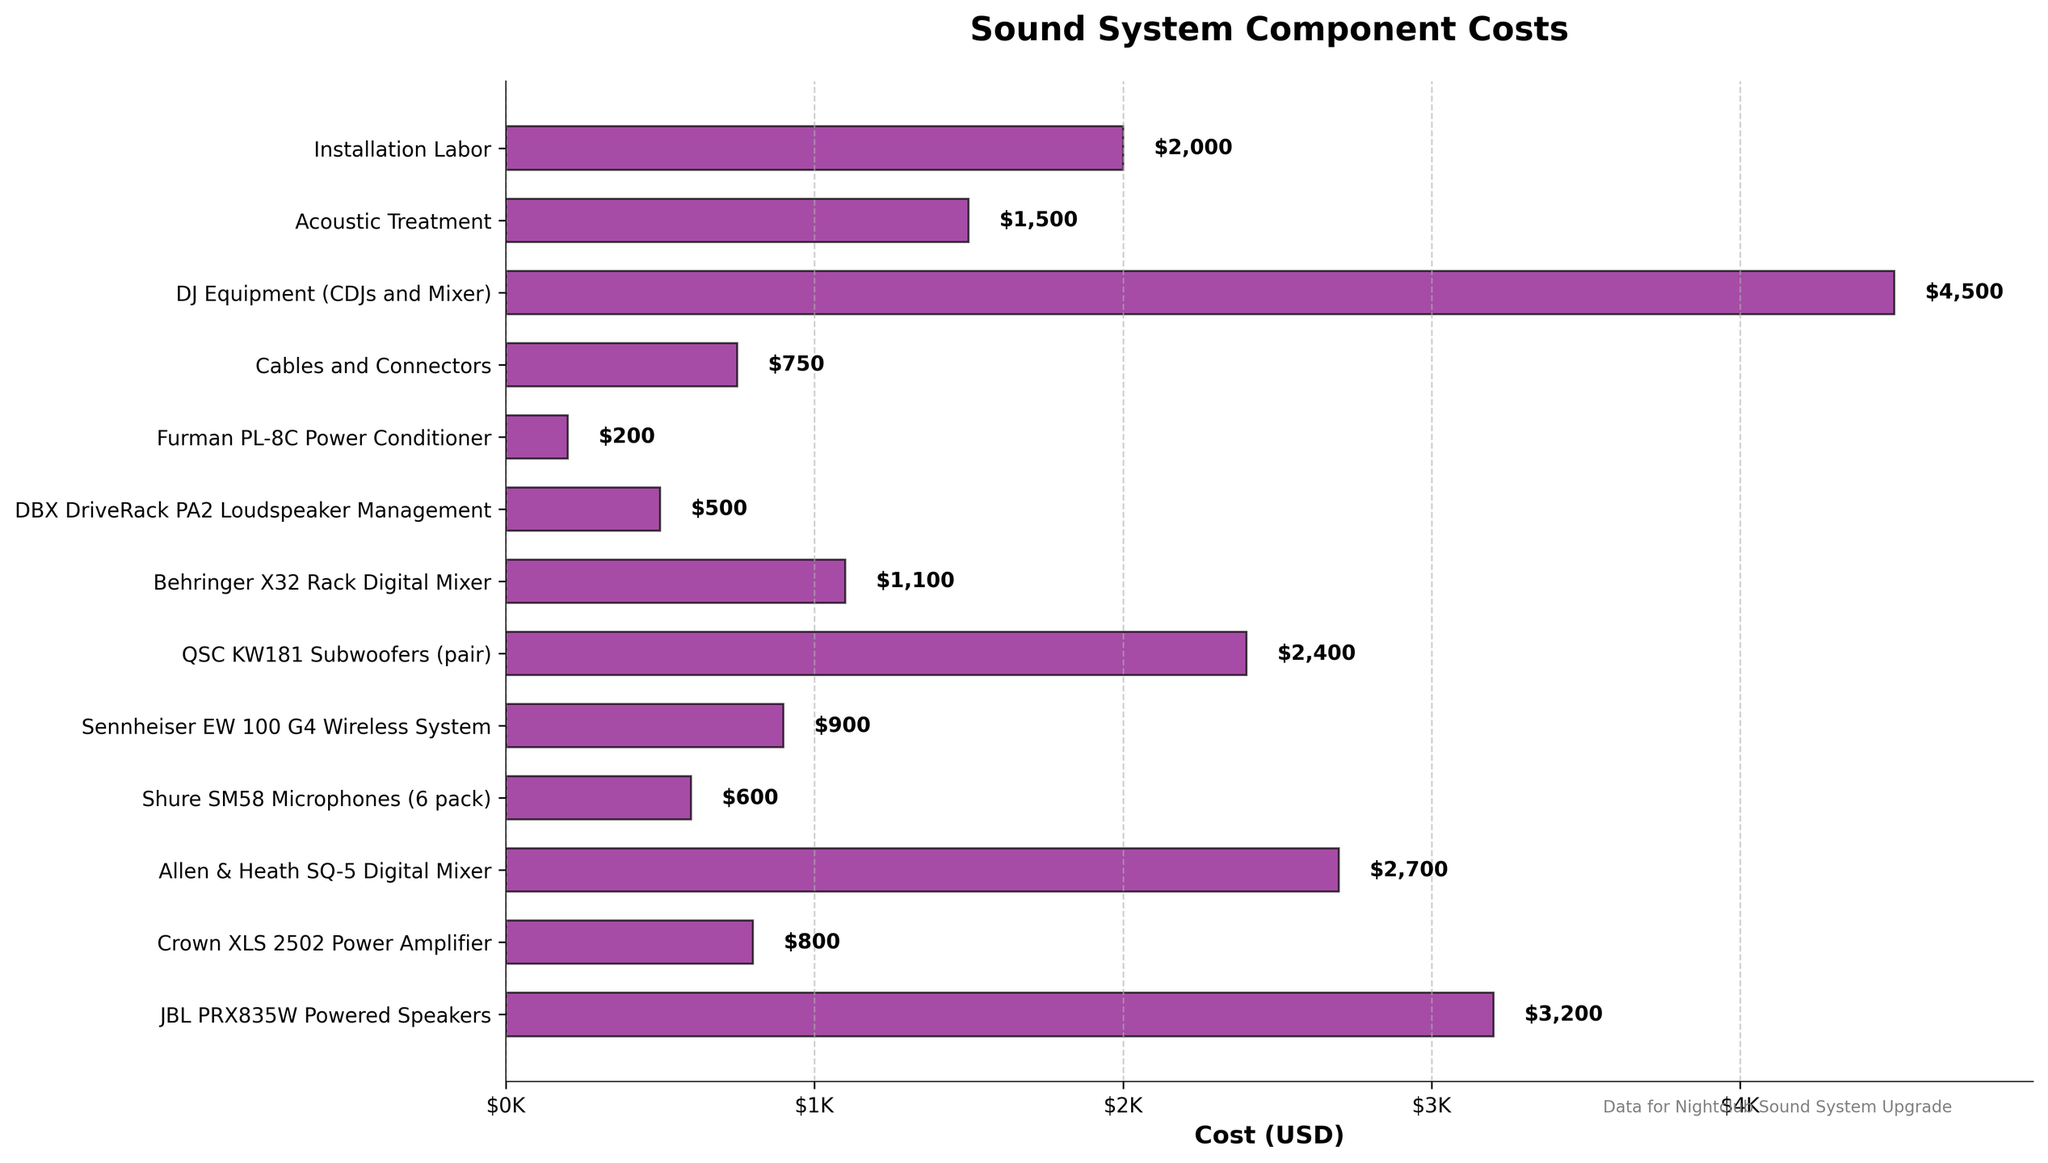What is the most expensive component in the sound system? The horizontal bar chart shows different components with their corresponding costs in USD. The longest bar corresponds to the DJ Equipment (CDJs and Mixer) with a cost of $4,500, which is the highest cost among all components.
Answer: DJ Equipment (CDJs and Mixer) What is the total cost of the digital mixers? The Allen & Heath SQ-5 Digital Mixer costs $2,700 and the Behringer X32 Rack Digital Mixer costs $1,100. Adding these two costs together gives $2,700 + $1,100 = $3,800.
Answer: $3,800 Which component is more expensive, the JBL PRX835W Powered Speakers or the QSC KW181 Subwoofers (pair)? Comparing the horizontal bar lengths, the JBL PRX835W Powered Speakers cost $3,200, while the QSC KW181 Subwoofers (pair) cost $2,400. Since $3,200 is greater than $2,400, the JBL PRX835W Powered Speakers are more expensive.
Answer: JBL PRX835W Powered Speakers What is the cost difference between the Installation Labor and the Acoustic Treatment? The Installation Labor costs $2,000 and the Acoustic Treatment costs $1,500. Subtracting these two amounts gives $2,000 - $1,500 = $500.
Answer: $500 Which component has the smallest cost? The horizontal bar chart indicates different costs, and the shortest bar corresponds to the Furman PL-8C Power Conditioner with a cost of $200.
Answer: Furman PL-8C Power Conditioner What is the average cost of the components listed in the chart? Sum all the costs listed for the components and divide by the number of components. Therefore, the total cost is $3200 + $800 + $2700 + $600 + $900 + $2400 + $1100 + $500 + $200 + $750 + $4500 + $1500 + $2000 = $21,150. There are 13 components, so the average cost is $21,150 / 13 = approximately $1,627.
Answer: $1,627 How much more expensive are the DJ Equipment (CDJs and Mixer) compared to the Shure SM58 Microphones (6 pack)? The DJ Equipment (CDJs and Mixer) costs $4,500 and the Shure SM58 Microphones (6 pack) costs $600. Subtracting these gives $4,500 - $600 = $3,900.
Answer: $3,900 Is the cost of the Cables and Connectors higher or lower than the cost of the Crown XLS 2502 Power Amplifier? The Cables and Connectors cost $750 and the Crown XLS 2502 Power Amplifier costs $800. Since $750 is less than $800, the cost of the Cables and Connectors is lower.
Answer: Lower 